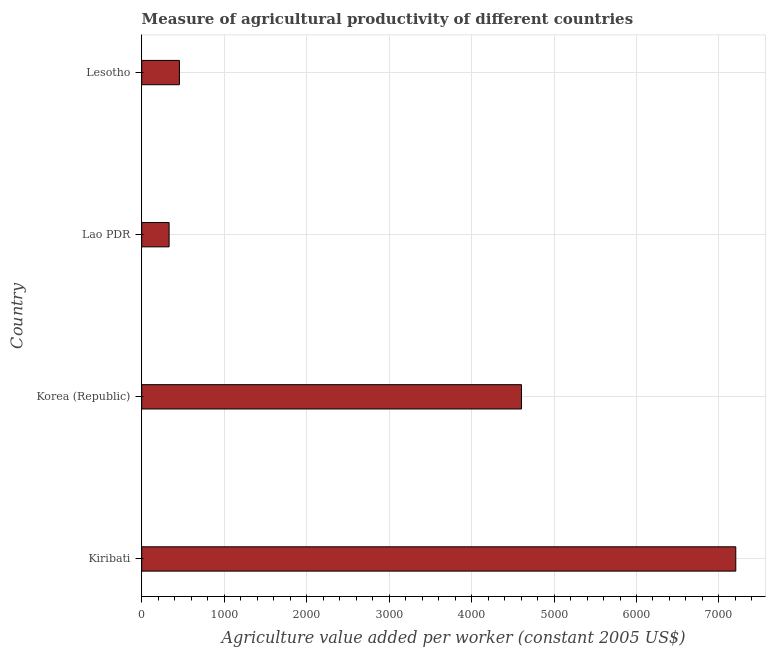Does the graph contain any zero values?
Your response must be concise. No. Does the graph contain grids?
Provide a short and direct response. Yes. What is the title of the graph?
Your response must be concise. Measure of agricultural productivity of different countries. What is the label or title of the X-axis?
Your response must be concise. Agriculture value added per worker (constant 2005 US$). What is the label or title of the Y-axis?
Provide a succinct answer. Country. What is the agriculture value added per worker in Lesotho?
Keep it short and to the point. 457.22. Across all countries, what is the maximum agriculture value added per worker?
Provide a short and direct response. 7204.15. Across all countries, what is the minimum agriculture value added per worker?
Provide a succinct answer. 332.12. In which country was the agriculture value added per worker maximum?
Keep it short and to the point. Kiribati. In which country was the agriculture value added per worker minimum?
Your answer should be compact. Lao PDR. What is the sum of the agriculture value added per worker?
Offer a very short reply. 1.26e+04. What is the difference between the agriculture value added per worker in Korea (Republic) and Lesotho?
Give a very brief answer. 4148.43. What is the average agriculture value added per worker per country?
Offer a terse response. 3149.79. What is the median agriculture value added per worker?
Make the answer very short. 2531.44. In how many countries, is the agriculture value added per worker greater than 200 US$?
Your answer should be compact. 4. What is the ratio of the agriculture value added per worker in Kiribati to that in Lao PDR?
Give a very brief answer. 21.69. What is the difference between the highest and the second highest agriculture value added per worker?
Offer a terse response. 2598.5. What is the difference between the highest and the lowest agriculture value added per worker?
Your answer should be very brief. 6872.04. What is the difference between two consecutive major ticks on the X-axis?
Your answer should be very brief. 1000. Are the values on the major ticks of X-axis written in scientific E-notation?
Your answer should be compact. No. What is the Agriculture value added per worker (constant 2005 US$) in Kiribati?
Provide a short and direct response. 7204.15. What is the Agriculture value added per worker (constant 2005 US$) in Korea (Republic)?
Offer a terse response. 4605.65. What is the Agriculture value added per worker (constant 2005 US$) in Lao PDR?
Make the answer very short. 332.12. What is the Agriculture value added per worker (constant 2005 US$) of Lesotho?
Provide a short and direct response. 457.22. What is the difference between the Agriculture value added per worker (constant 2005 US$) in Kiribati and Korea (Republic)?
Make the answer very short. 2598.5. What is the difference between the Agriculture value added per worker (constant 2005 US$) in Kiribati and Lao PDR?
Provide a succinct answer. 6872.04. What is the difference between the Agriculture value added per worker (constant 2005 US$) in Kiribati and Lesotho?
Offer a very short reply. 6746.93. What is the difference between the Agriculture value added per worker (constant 2005 US$) in Korea (Republic) and Lao PDR?
Offer a terse response. 4273.53. What is the difference between the Agriculture value added per worker (constant 2005 US$) in Korea (Republic) and Lesotho?
Give a very brief answer. 4148.43. What is the difference between the Agriculture value added per worker (constant 2005 US$) in Lao PDR and Lesotho?
Ensure brevity in your answer.  -125.1. What is the ratio of the Agriculture value added per worker (constant 2005 US$) in Kiribati to that in Korea (Republic)?
Ensure brevity in your answer.  1.56. What is the ratio of the Agriculture value added per worker (constant 2005 US$) in Kiribati to that in Lao PDR?
Keep it short and to the point. 21.69. What is the ratio of the Agriculture value added per worker (constant 2005 US$) in Kiribati to that in Lesotho?
Make the answer very short. 15.76. What is the ratio of the Agriculture value added per worker (constant 2005 US$) in Korea (Republic) to that in Lao PDR?
Ensure brevity in your answer.  13.87. What is the ratio of the Agriculture value added per worker (constant 2005 US$) in Korea (Republic) to that in Lesotho?
Your response must be concise. 10.07. What is the ratio of the Agriculture value added per worker (constant 2005 US$) in Lao PDR to that in Lesotho?
Provide a short and direct response. 0.73. 